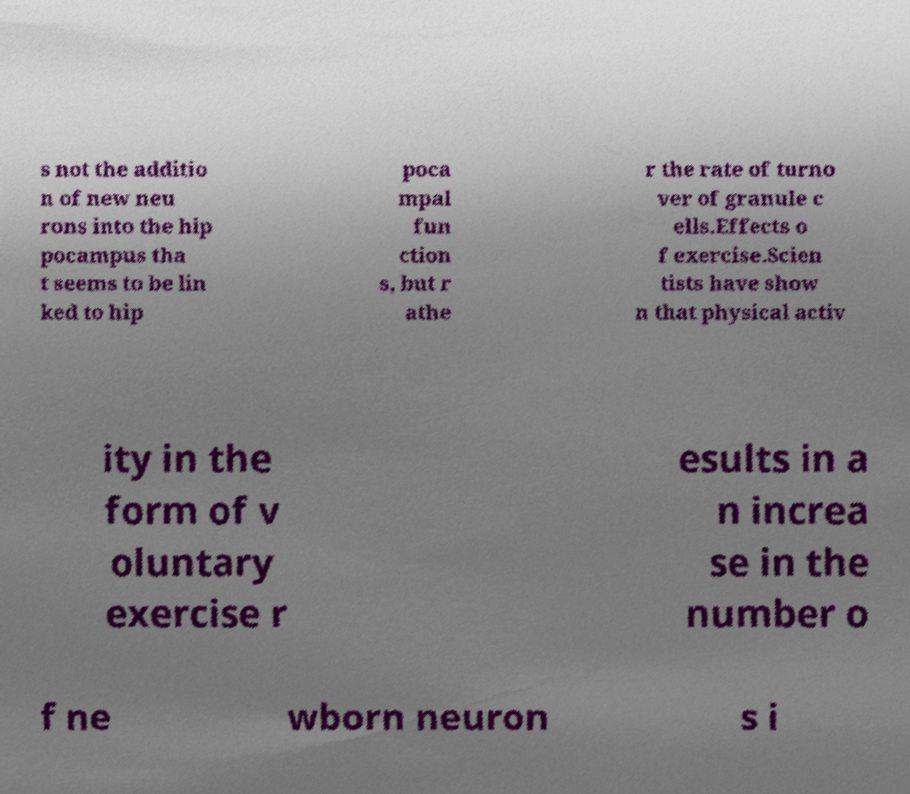Can you accurately transcribe the text from the provided image for me? s not the additio n of new neu rons into the hip pocampus tha t seems to be lin ked to hip poca mpal fun ction s, but r athe r the rate of turno ver of granule c ells.Effects o f exercise.Scien tists have show n that physical activ ity in the form of v oluntary exercise r esults in a n increa se in the number o f ne wborn neuron s i 